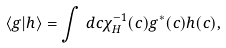<formula> <loc_0><loc_0><loc_500><loc_500>\langle g | h \rangle = \int \, d c \chi _ { H } ^ { - 1 } ( c ) g ^ { * } ( c ) h ( c ) ,</formula> 